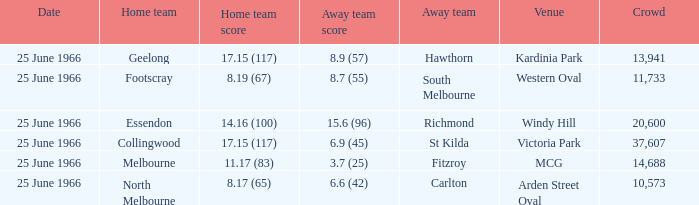What is the total crowd size when a home team scored 17.15 (117) versus hawthorn? 13941.0. 